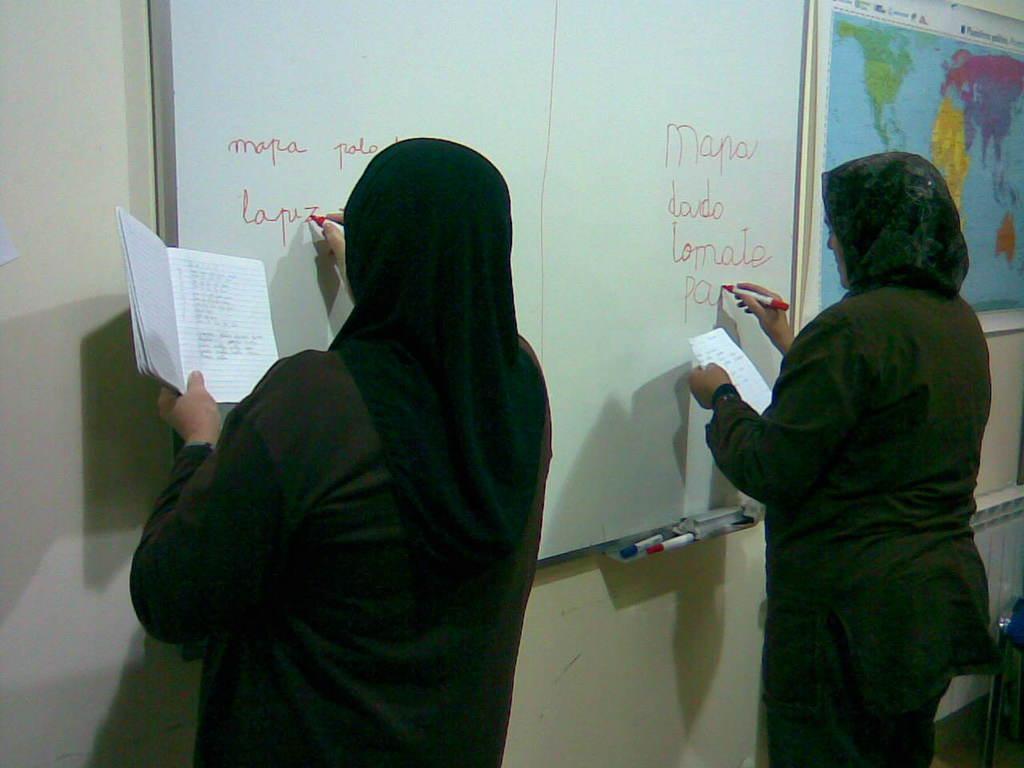How would you summarize this image in a sentence or two? In this image, we can see two people are writing some information with marker on the whiteboard and holding some objects. Here there is a wall, map, few things. 